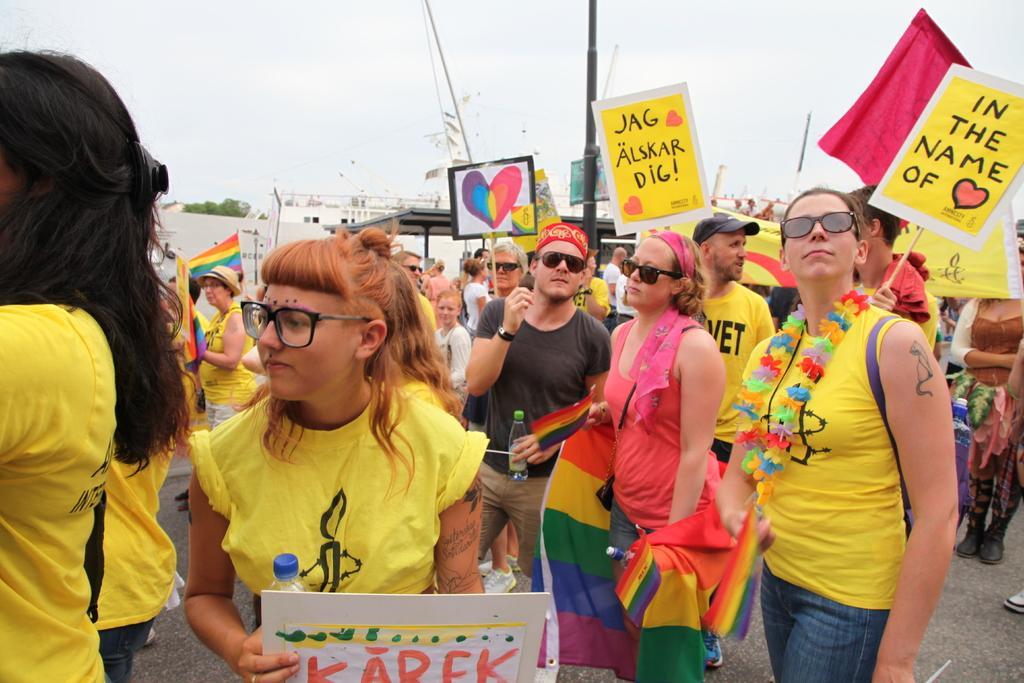In one or two sentences, can you explain what this image depicts? In this image there are so many people standing on road holding some placards, behind them there are some buildings and trees. 